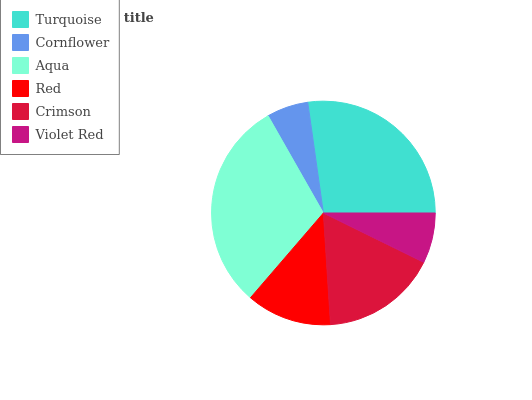Is Cornflower the minimum?
Answer yes or no. Yes. Is Aqua the maximum?
Answer yes or no. Yes. Is Aqua the minimum?
Answer yes or no. No. Is Cornflower the maximum?
Answer yes or no. No. Is Aqua greater than Cornflower?
Answer yes or no. Yes. Is Cornflower less than Aqua?
Answer yes or no. Yes. Is Cornflower greater than Aqua?
Answer yes or no. No. Is Aqua less than Cornflower?
Answer yes or no. No. Is Crimson the high median?
Answer yes or no. Yes. Is Red the low median?
Answer yes or no. Yes. Is Aqua the high median?
Answer yes or no. No. Is Turquoise the low median?
Answer yes or no. No. 